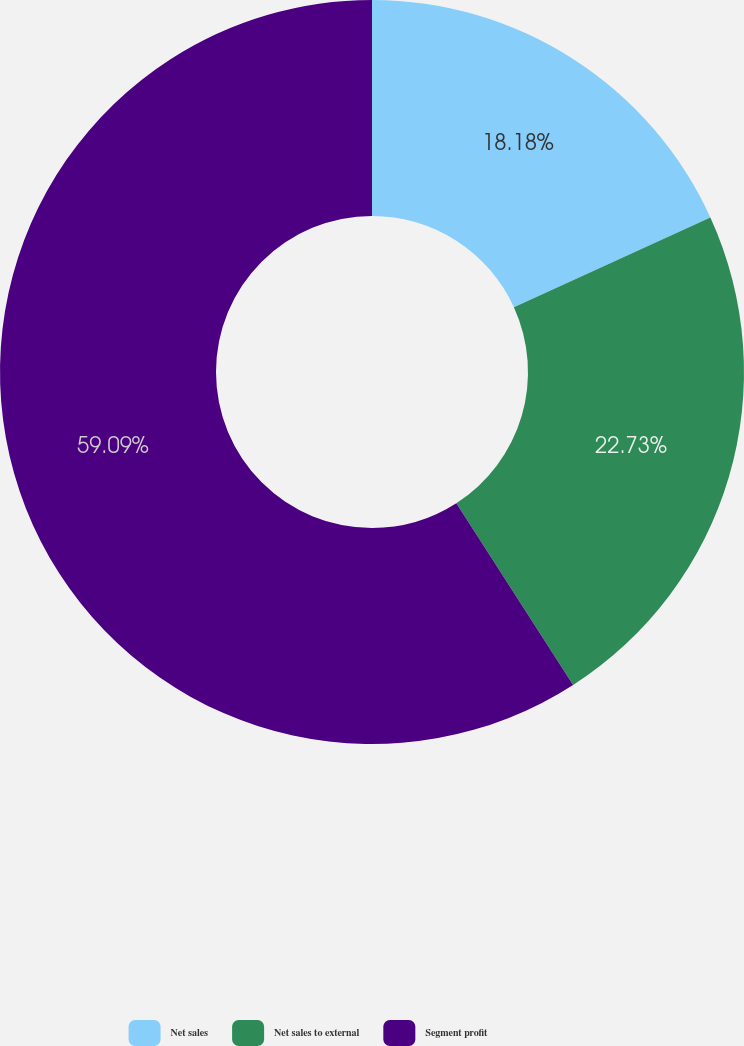<chart> <loc_0><loc_0><loc_500><loc_500><pie_chart><fcel>Net sales<fcel>Net sales to external<fcel>Segment profit<nl><fcel>18.18%<fcel>22.73%<fcel>59.09%<nl></chart> 